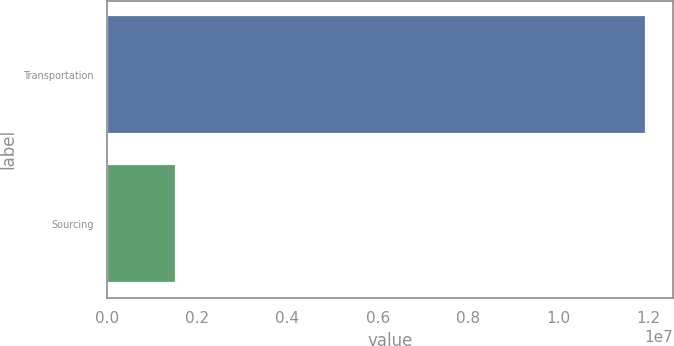Convert chart to OTSL. <chart><loc_0><loc_0><loc_500><loc_500><bar_chart><fcel>Transportation<fcel>Sourcing<nl><fcel>1.19365e+07<fcel>1.53356e+06<nl></chart> 